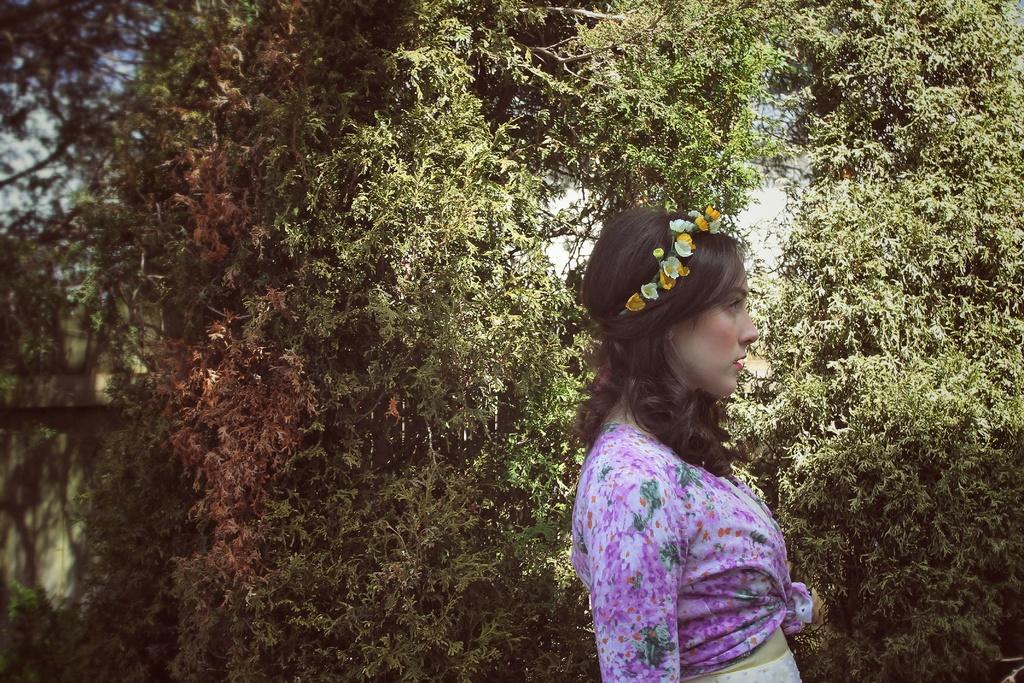In one or two sentences, can you explain what this image depicts? In this image we can see a woman standing on the ground and wearing tiara. In the background we can see trees and sky. 